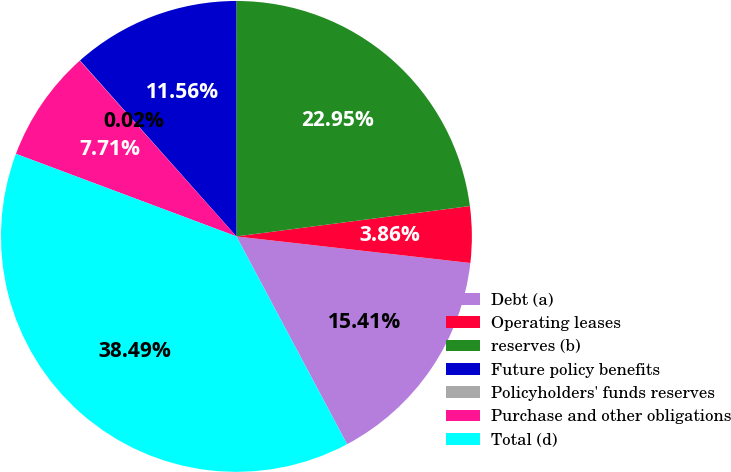Convert chart to OTSL. <chart><loc_0><loc_0><loc_500><loc_500><pie_chart><fcel>Debt (a)<fcel>Operating leases<fcel>reserves (b)<fcel>Future policy benefits<fcel>Policyholders' funds reserves<fcel>Purchase and other obligations<fcel>Total (d)<nl><fcel>15.41%<fcel>3.86%<fcel>22.95%<fcel>11.56%<fcel>0.02%<fcel>7.71%<fcel>38.49%<nl></chart> 